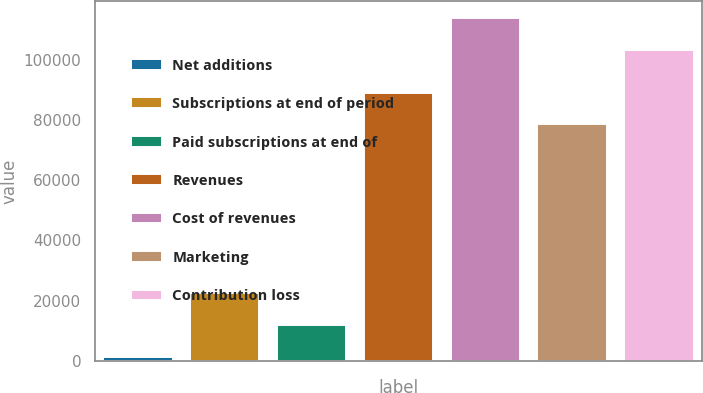Convert chart to OTSL. <chart><loc_0><loc_0><loc_500><loc_500><bar_chart><fcel>Net additions<fcel>Subscriptions at end of period<fcel>Paid subscriptions at end of<fcel>Revenues<fcel>Cost of revenues<fcel>Marketing<fcel>Contribution loss<nl><fcel>1349<fcel>22575.6<fcel>11962.3<fcel>89130.3<fcel>113762<fcel>78517<fcel>103149<nl></chart> 